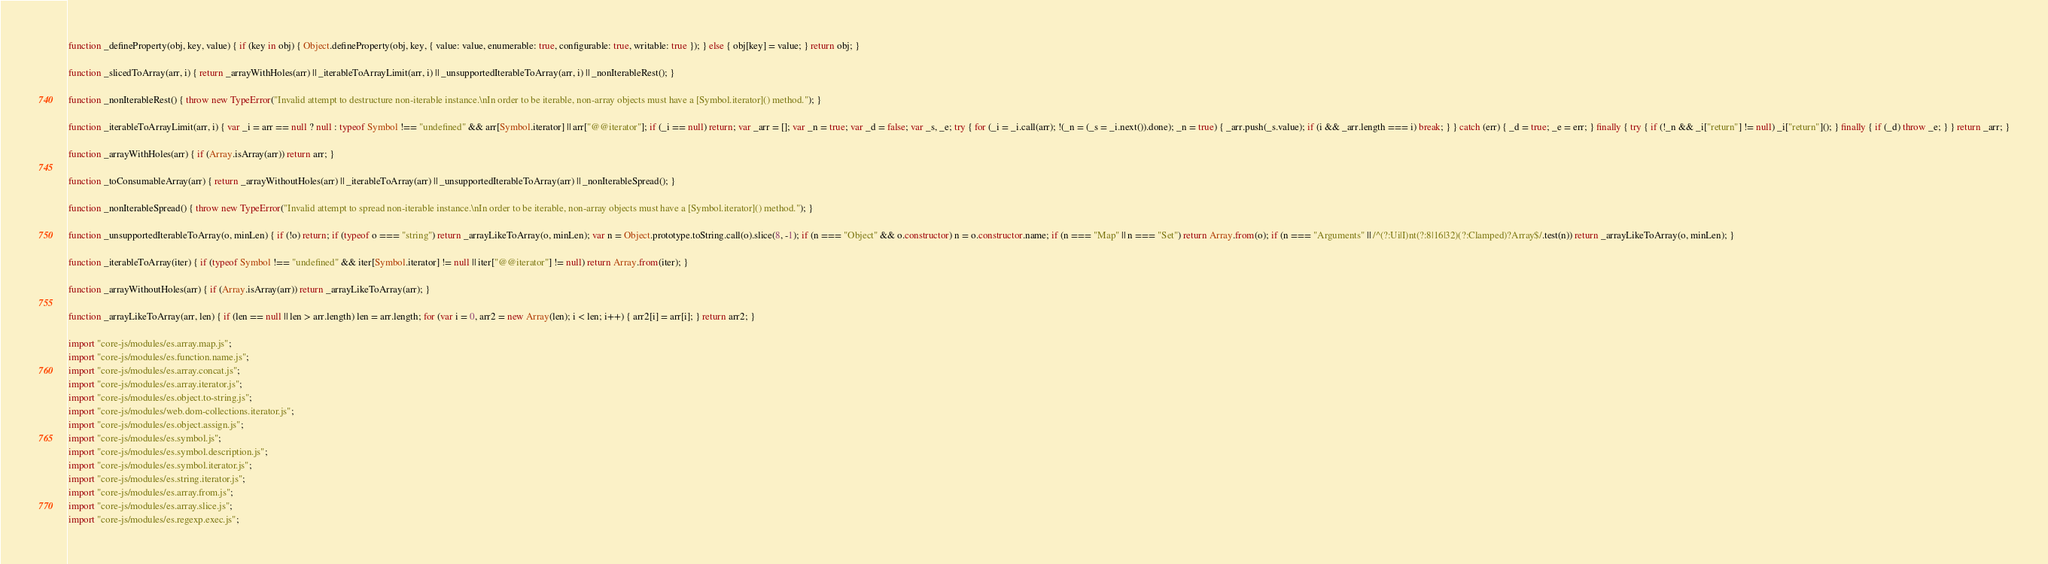<code> <loc_0><loc_0><loc_500><loc_500><_JavaScript_>function _defineProperty(obj, key, value) { if (key in obj) { Object.defineProperty(obj, key, { value: value, enumerable: true, configurable: true, writable: true }); } else { obj[key] = value; } return obj; }

function _slicedToArray(arr, i) { return _arrayWithHoles(arr) || _iterableToArrayLimit(arr, i) || _unsupportedIterableToArray(arr, i) || _nonIterableRest(); }

function _nonIterableRest() { throw new TypeError("Invalid attempt to destructure non-iterable instance.\nIn order to be iterable, non-array objects must have a [Symbol.iterator]() method."); }

function _iterableToArrayLimit(arr, i) { var _i = arr == null ? null : typeof Symbol !== "undefined" && arr[Symbol.iterator] || arr["@@iterator"]; if (_i == null) return; var _arr = []; var _n = true; var _d = false; var _s, _e; try { for (_i = _i.call(arr); !(_n = (_s = _i.next()).done); _n = true) { _arr.push(_s.value); if (i && _arr.length === i) break; } } catch (err) { _d = true; _e = err; } finally { try { if (!_n && _i["return"] != null) _i["return"](); } finally { if (_d) throw _e; } } return _arr; }

function _arrayWithHoles(arr) { if (Array.isArray(arr)) return arr; }

function _toConsumableArray(arr) { return _arrayWithoutHoles(arr) || _iterableToArray(arr) || _unsupportedIterableToArray(arr) || _nonIterableSpread(); }

function _nonIterableSpread() { throw new TypeError("Invalid attempt to spread non-iterable instance.\nIn order to be iterable, non-array objects must have a [Symbol.iterator]() method."); }

function _unsupportedIterableToArray(o, minLen) { if (!o) return; if (typeof o === "string") return _arrayLikeToArray(o, minLen); var n = Object.prototype.toString.call(o).slice(8, -1); if (n === "Object" && o.constructor) n = o.constructor.name; if (n === "Map" || n === "Set") return Array.from(o); if (n === "Arguments" || /^(?:Ui|I)nt(?:8|16|32)(?:Clamped)?Array$/.test(n)) return _arrayLikeToArray(o, minLen); }

function _iterableToArray(iter) { if (typeof Symbol !== "undefined" && iter[Symbol.iterator] != null || iter["@@iterator"] != null) return Array.from(iter); }

function _arrayWithoutHoles(arr) { if (Array.isArray(arr)) return _arrayLikeToArray(arr); }

function _arrayLikeToArray(arr, len) { if (len == null || len > arr.length) len = arr.length; for (var i = 0, arr2 = new Array(len); i < len; i++) { arr2[i] = arr[i]; } return arr2; }

import "core-js/modules/es.array.map.js";
import "core-js/modules/es.function.name.js";
import "core-js/modules/es.array.concat.js";
import "core-js/modules/es.array.iterator.js";
import "core-js/modules/es.object.to-string.js";
import "core-js/modules/web.dom-collections.iterator.js";
import "core-js/modules/es.object.assign.js";
import "core-js/modules/es.symbol.js";
import "core-js/modules/es.symbol.description.js";
import "core-js/modules/es.symbol.iterator.js";
import "core-js/modules/es.string.iterator.js";
import "core-js/modules/es.array.from.js";
import "core-js/modules/es.array.slice.js";
import "core-js/modules/es.regexp.exec.js";</code> 